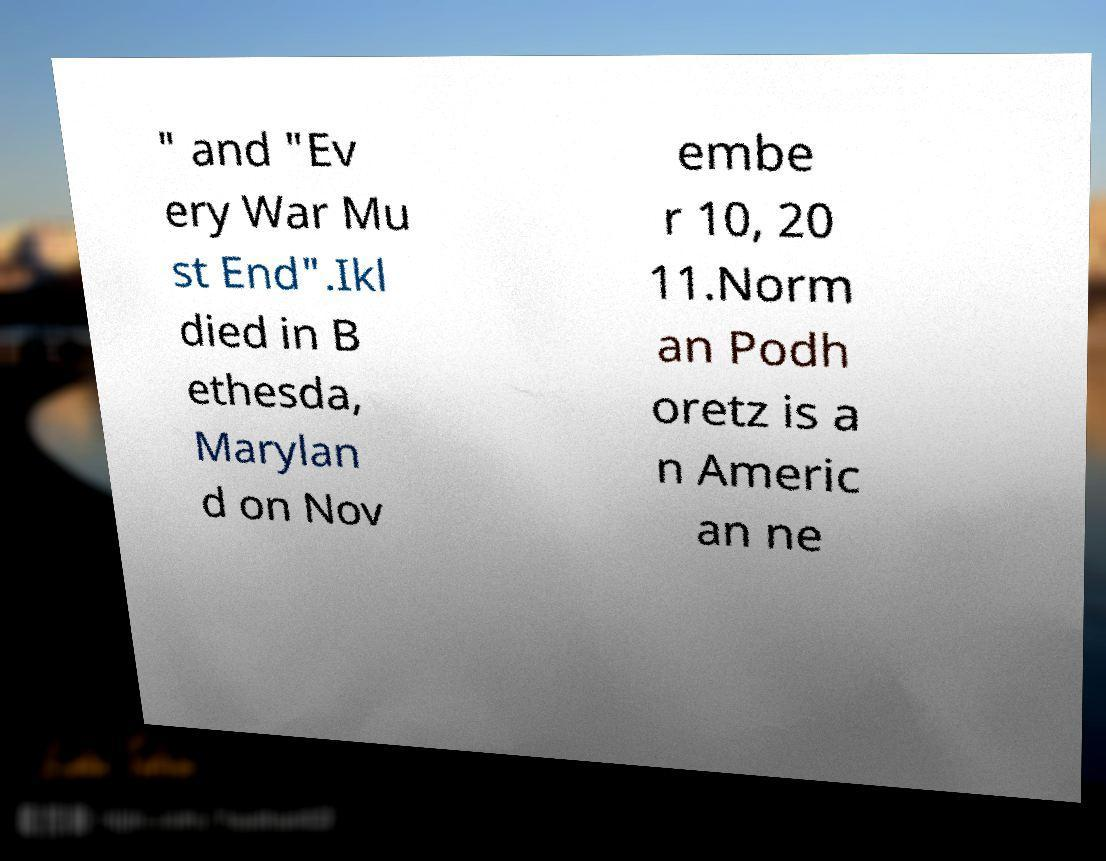Please read and relay the text visible in this image. What does it say? " and "Ev ery War Mu st End".Ikl died in B ethesda, Marylan d on Nov embe r 10, 20 11.Norm an Podh oretz is a n Americ an ne 